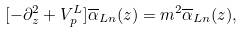<formula> <loc_0><loc_0><loc_500><loc_500>[ - \partial ^ { 2 } _ { z } + V _ { p } ^ { L } ] \overline { \alpha } _ { L n } ( z ) = m ^ { 2 } \overline { \alpha } _ { L n } ( z ) ,</formula> 